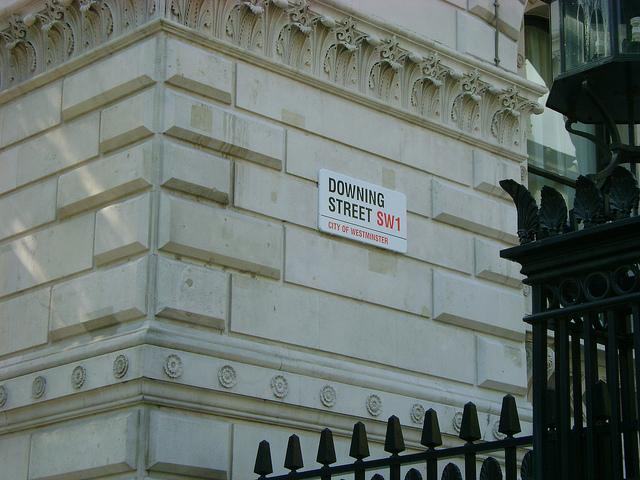Is there a clock in this image?
Answer briefly. No. Are there soffits under the roof overhangs?
Concise answer only. Yes. What time of day is this?
Quick response, please. Afternoon. Is part of the building brick?
Short answer required. No. What season is depicted in this photo?
Concise answer only. Summer. Is there a clock on the building?
Concise answer only. No. What is the purpose of this building?
Give a very brief answer. Government. What city is Downing Street SW1?
Concise answer only. London. What is the fence made of?
Answer briefly. Iron. 